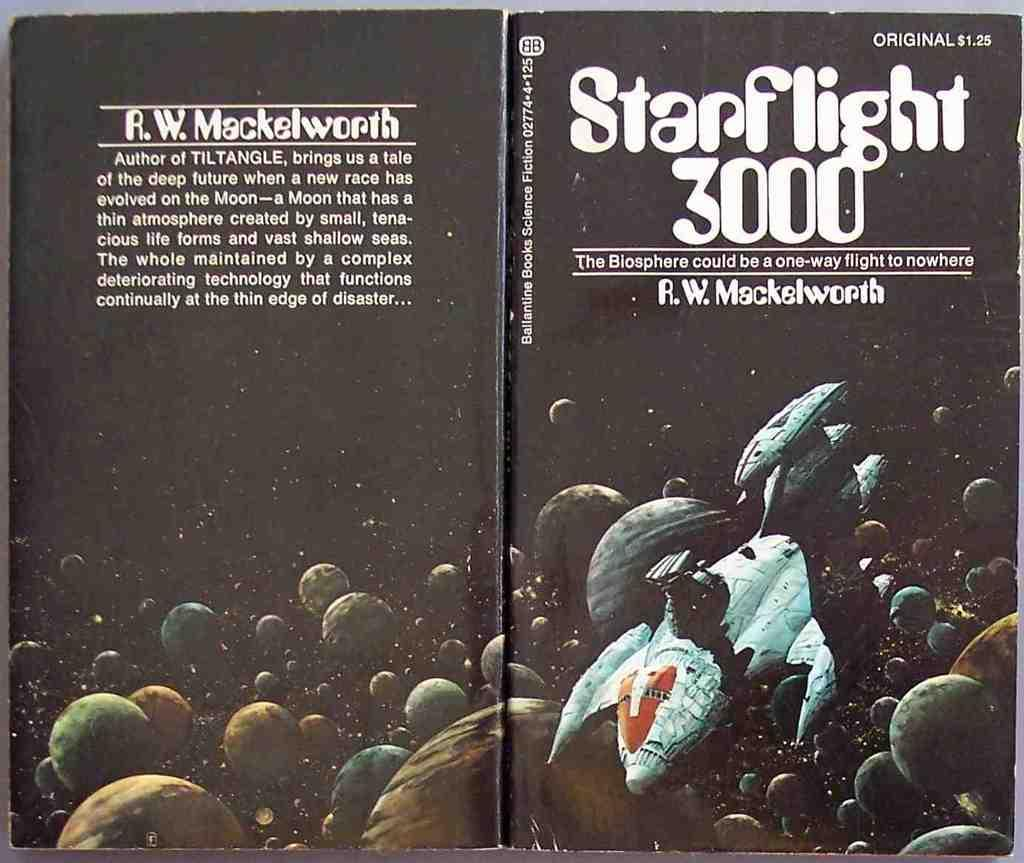Provide a one-sentence caption for the provided image. An open book called Starflight 3000 with a spaceship flying by planets on it. 